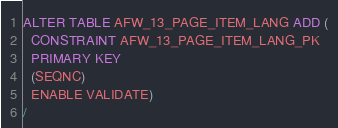<code> <loc_0><loc_0><loc_500><loc_500><_SQL_>ALTER TABLE AFW_13_PAGE_ITEM_LANG ADD (
  CONSTRAINT AFW_13_PAGE_ITEM_LANG_PK
  PRIMARY KEY
  (SEQNC)
  ENABLE VALIDATE)
/
</code> 